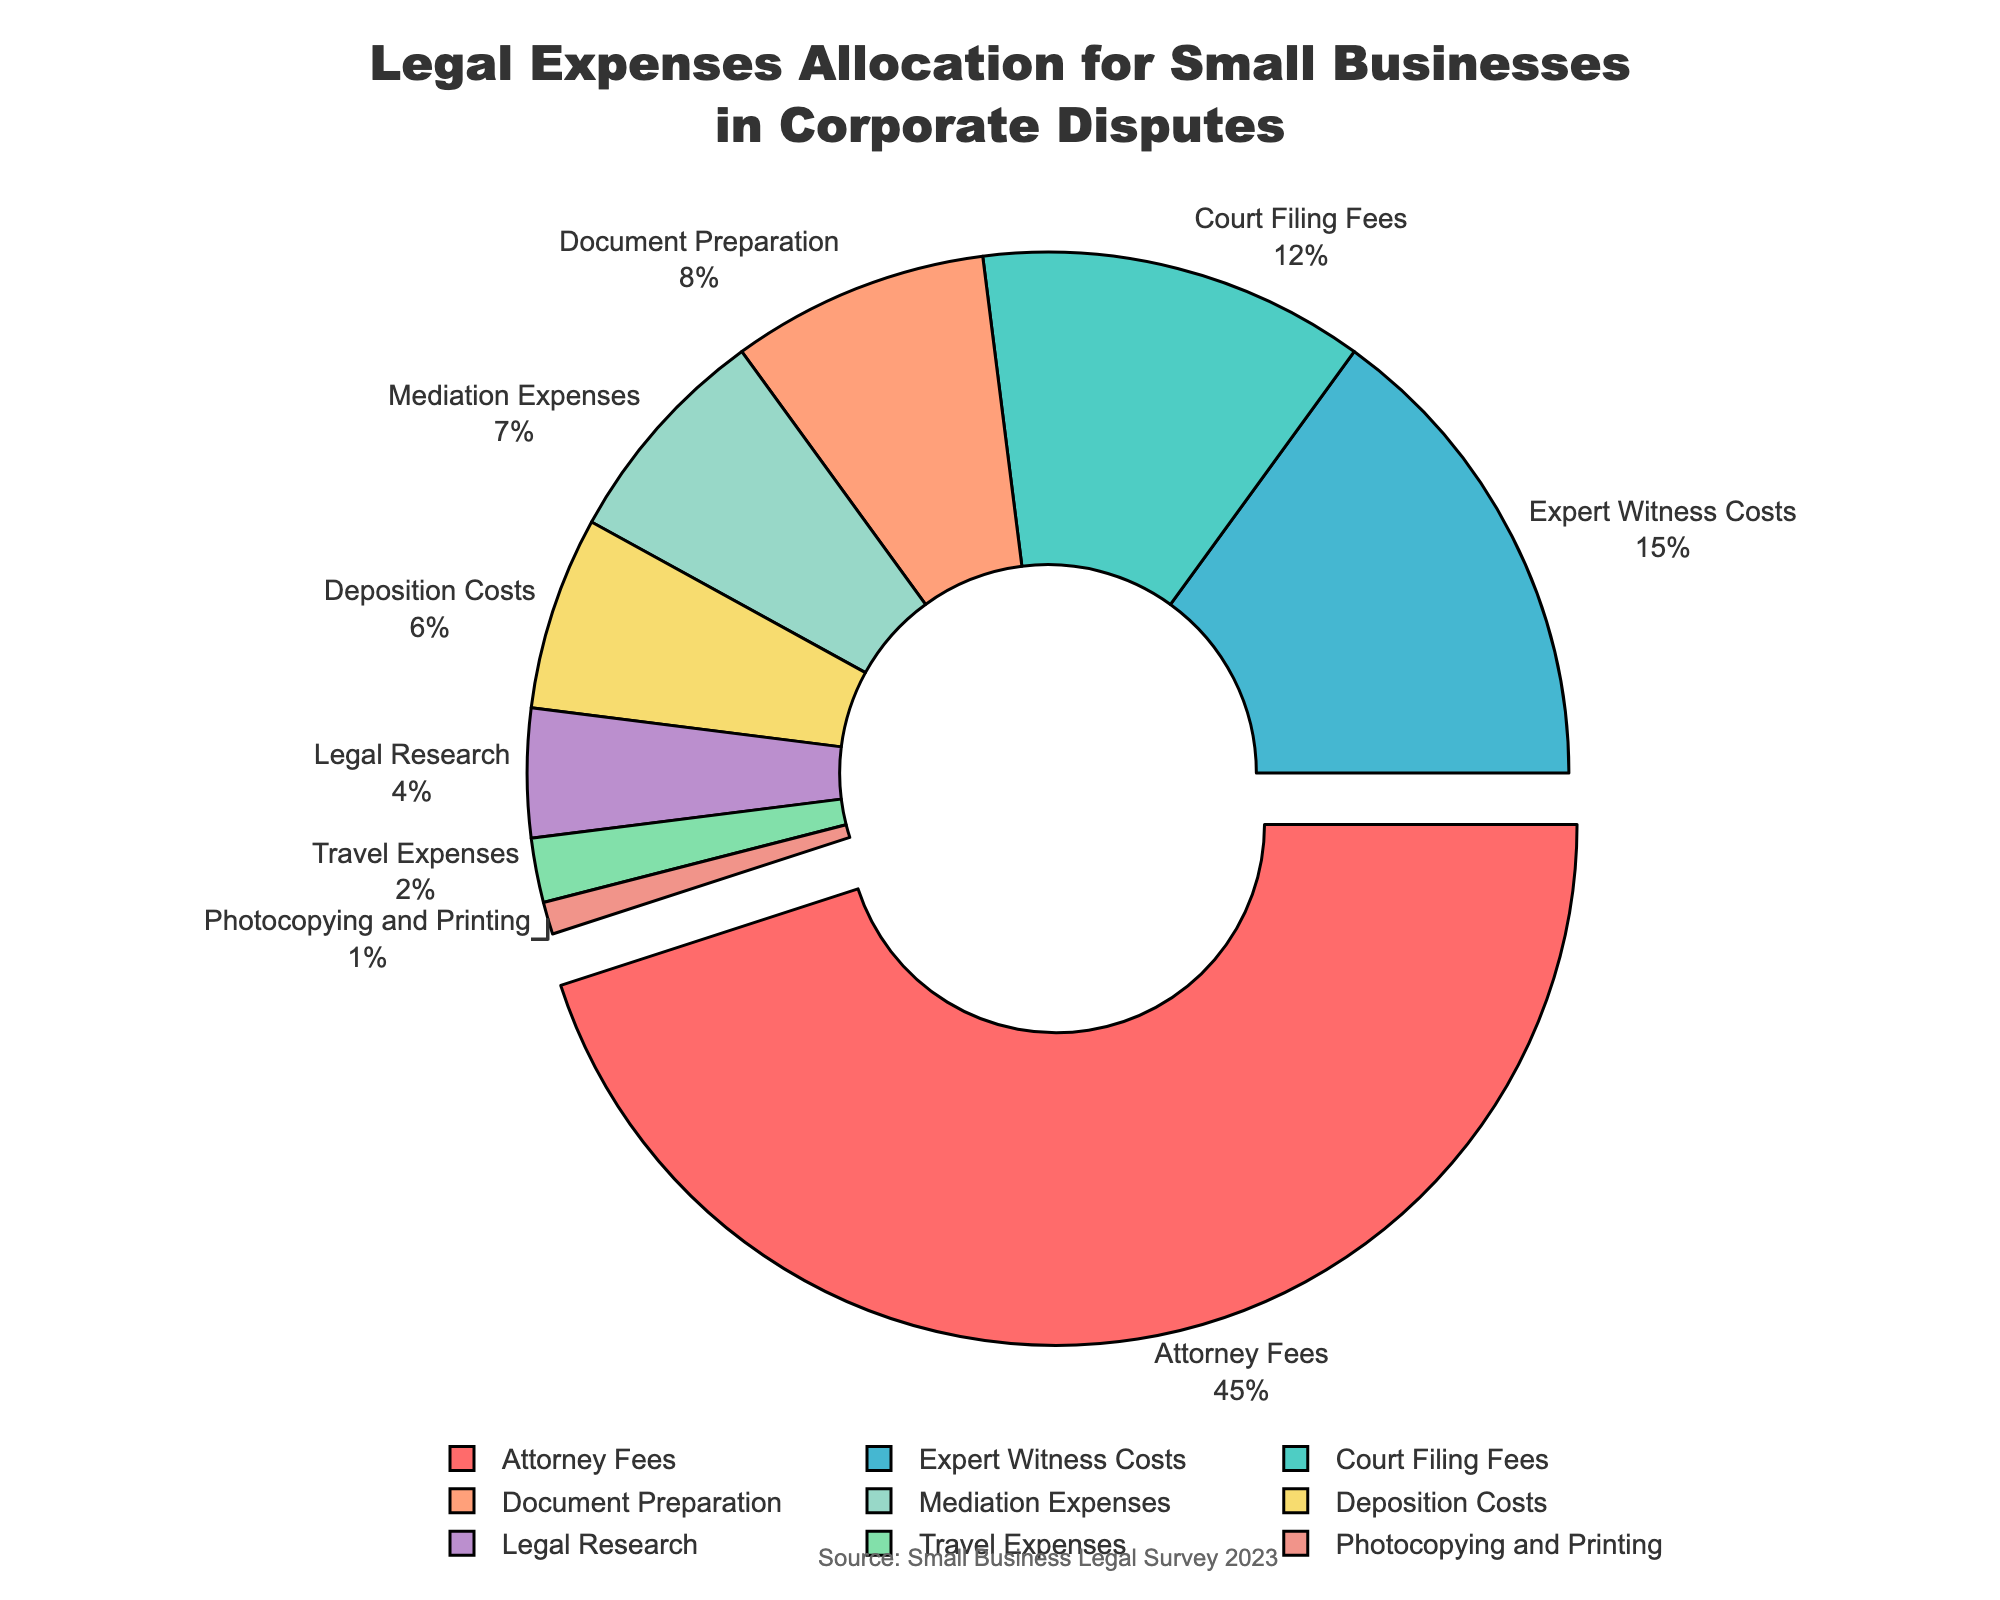What's the category with the highest percentage allocation? The category with the highest percentage allocation is visibly the one pulled out in the pie chart, which is 'Attorney Fees'. The percentage amount for 'Attorney Fees' is 45%, which is higher than the other categories.
Answer: Attorney Fees What's the combined percentage for Court Filing Fees and Expert Witness Costs? From the pie chart for legal expenses allocation, the percentages for 'Court Filing Fees' and 'Expert Witness Costs' are 12% and 15%, respectively. The combined percentage is 12% + 15% = 27%.
Answer: 27% Which expense category represents the smallest portion of legal costs? The pie chart shows 'Photocopying and Printing' as the smallest segment of the chart, with 1%.
Answer: Photocopying and Printing How much more, percentage-wise, is allocated to Attorney Fees compared to Mediation Expenses? 'Attorney Fees' is 45% and 'Mediation Expenses' is 7%. The difference in allocation is 45% - 7% = 38%.
Answer: 38% What is the percentage difference between Expert Witness Costs and Deposition Costs? The percentages for 'Expert Witness Costs' and 'Deposition Costs' are 15% and 6%, respectively. The difference is 15% - 6% = 9%.
Answer: 9% Which three categories together sum up close to 50% of the total legal costs? Based on the chart, 'Court Filing Fees' (12%), 'Expert Witness Costs' (15%), and 'Document Preparation' (8%) together add up to 12% + 15% + 8% = 35%. Including just one more category like 'Mediation Expenses' (7%) would result in a sum of 35% + 7% = 42%, still below 50%. Thus, there's no exact combination of three categories summing to 50%.
Answer: None Is the allocation for Travel Expenses greater than Legal Research? 'Travel Expenses' is represented as 2%, whereas 'Legal Research' is 4%. Therefore, Travel Expenses is not greater than Legal Research.
Answer: No What is the total percentage for Document Preparation, Mediation Expenses, and Deposition Costs combined? Adding the percentages for 'Document Preparation' (8%), 'Mediation Expenses' (7%), and 'Deposition Costs' (6%) yields 8% + 7% + 6% = 21%.
Answer: 21% Which expense categories are below 10% individually? From the pie chart, the categories below 10% individually are 'Document Preparation' (8%), 'Mediation Expenses' (7%), 'Deposition Costs' (6%), 'Legal Research' (4%), 'Travel Expenses' (2%), and 'Photocopying and Printing' (1%).
Answer: Document Preparation, Mediation Expenses, Deposition Costs, Legal Research, Travel Expenses, Photocopying and Printing 